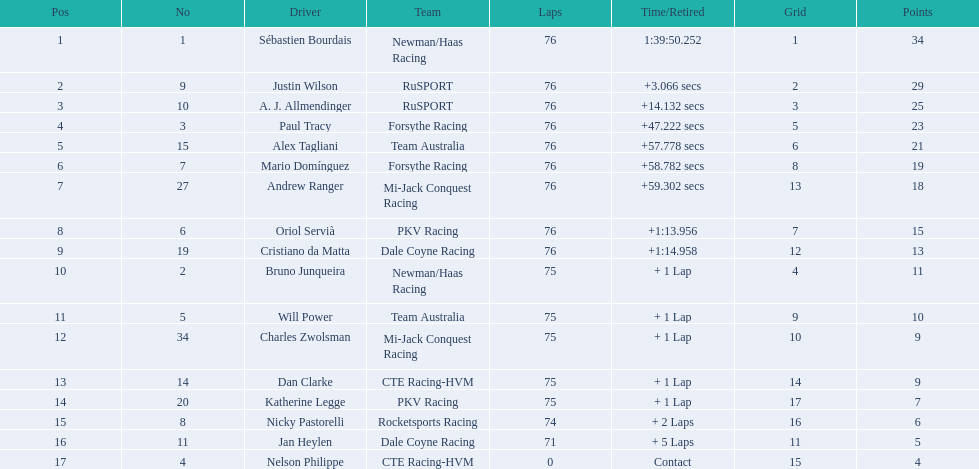Which drivers completed all 76 laps? Sébastien Bourdais, Justin Wilson, A. J. Allmendinger, Paul Tracy, Alex Tagliani, Mario Domínguez, Andrew Ranger, Oriol Servià, Cristiano da Matta. Of these drivers, which ones finished less than a minute behind first place? Paul Tracy, Alex Tagliani, Mario Domínguez, Andrew Ranger. Of these drivers, which ones finished with a time less than 50 seconds behind first place? Justin Wilson, A. J. Allmendinger, Paul Tracy. Of these three drivers, who finished last? Paul Tracy. 